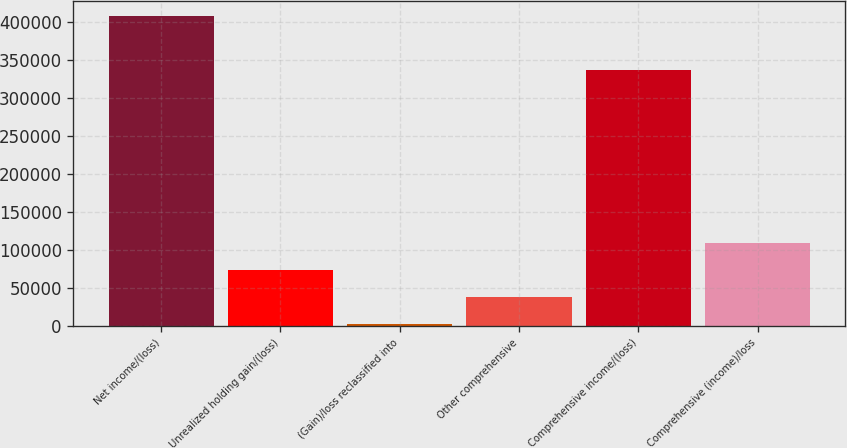Convert chart to OTSL. <chart><loc_0><loc_0><loc_500><loc_500><bar_chart><fcel>Net income/(loss)<fcel>Unrealized holding gain/(loss)<fcel>(Gain)/loss reclassified into<fcel>Other comprehensive<fcel>Comprehensive income/(loss)<fcel>Comprehensive (income)/loss<nl><fcel>407539<fcel>73241.4<fcel>2262<fcel>37751.7<fcel>336560<fcel>108731<nl></chart> 